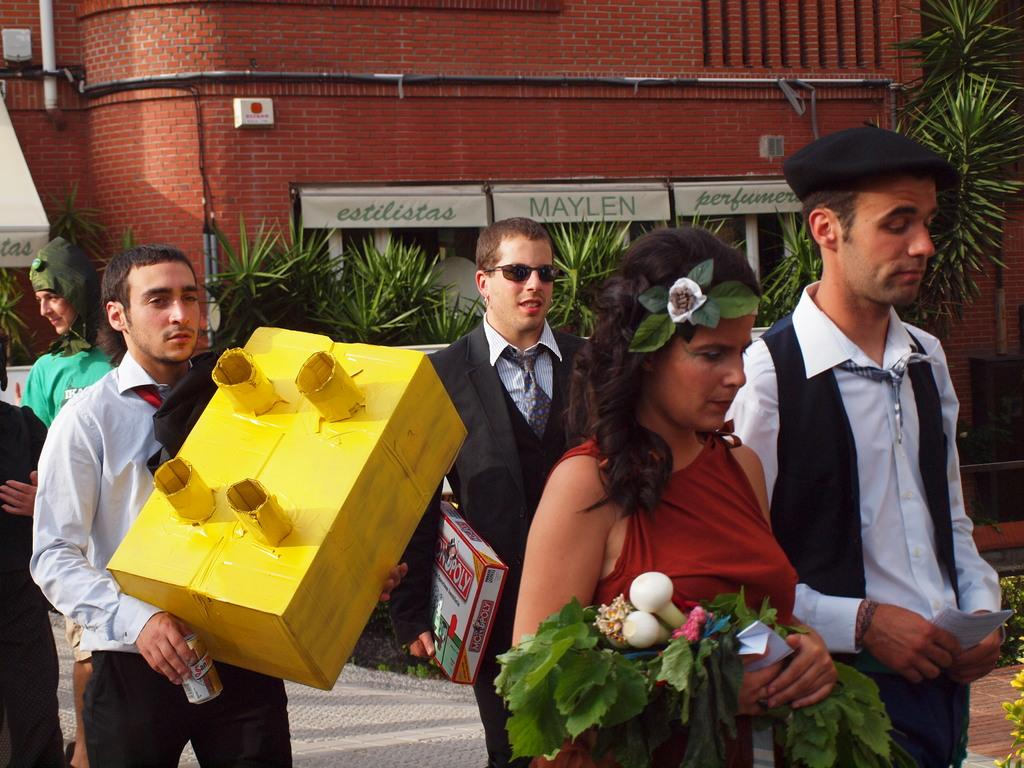Who is present in the image? There are people in the image. What are the people doing in the image? The people are walking. What are the people holding in the image? The people are holding boxes, papers, and leaves. What can be seen in the background of the image? There are plants and buildings visible in the background of the image. What type of soda is being served at the sister's ice-skating event in the image? There is no mention of a sister, ice-skating event, or soda in the image. 